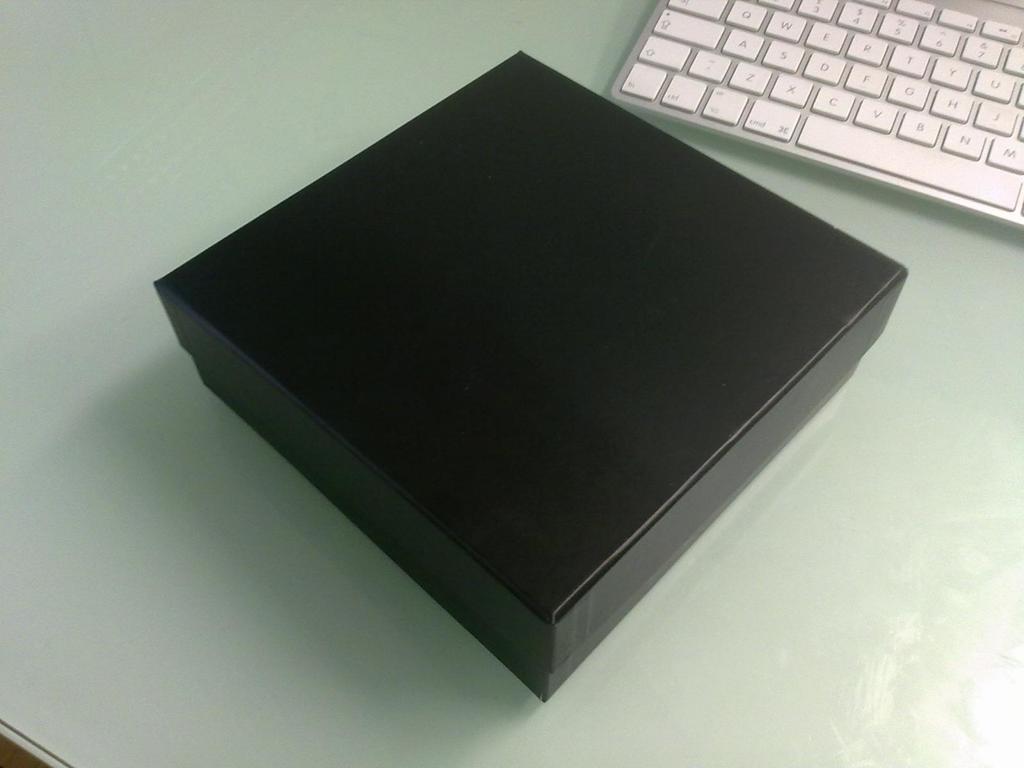What letter aligns with the spacebar that is one row above?
Keep it short and to the point. C. 